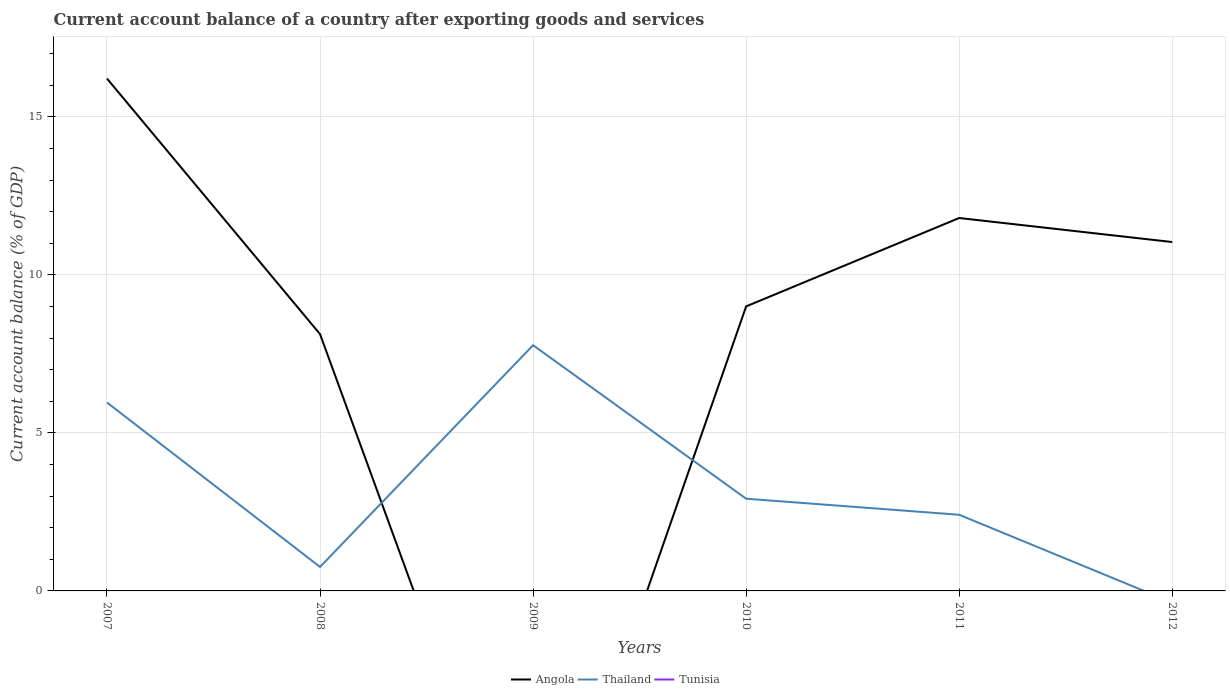How many different coloured lines are there?
Provide a short and direct response. 2. Across all years, what is the maximum account balance in Tunisia?
Offer a terse response. 0. What is the total account balance in Thailand in the graph?
Provide a short and direct response. 5.36. What is the difference between the highest and the second highest account balance in Angola?
Keep it short and to the point. 16.21. What is the difference between the highest and the lowest account balance in Tunisia?
Make the answer very short. 0. Is the account balance in Tunisia strictly greater than the account balance in Angola over the years?
Give a very brief answer. No. What is the difference between two consecutive major ticks on the Y-axis?
Keep it short and to the point. 5. Does the graph contain any zero values?
Your answer should be compact. Yes. Does the graph contain grids?
Make the answer very short. Yes. How many legend labels are there?
Keep it short and to the point. 3. What is the title of the graph?
Offer a terse response. Current account balance of a country after exporting goods and services. Does "Swaziland" appear as one of the legend labels in the graph?
Provide a succinct answer. No. What is the label or title of the Y-axis?
Offer a very short reply. Current account balance (% of GDP). What is the Current account balance (% of GDP) in Angola in 2007?
Give a very brief answer. 16.21. What is the Current account balance (% of GDP) of Thailand in 2007?
Ensure brevity in your answer.  5.96. What is the Current account balance (% of GDP) in Tunisia in 2007?
Provide a short and direct response. 0. What is the Current account balance (% of GDP) of Angola in 2008?
Your answer should be very brief. 8.13. What is the Current account balance (% of GDP) in Thailand in 2008?
Keep it short and to the point. 0.76. What is the Current account balance (% of GDP) in Thailand in 2009?
Your answer should be compact. 7.77. What is the Current account balance (% of GDP) of Tunisia in 2009?
Ensure brevity in your answer.  0. What is the Current account balance (% of GDP) of Angola in 2010?
Give a very brief answer. 9. What is the Current account balance (% of GDP) of Thailand in 2010?
Offer a very short reply. 2.92. What is the Current account balance (% of GDP) of Tunisia in 2010?
Offer a very short reply. 0. What is the Current account balance (% of GDP) in Angola in 2011?
Make the answer very short. 11.8. What is the Current account balance (% of GDP) of Thailand in 2011?
Give a very brief answer. 2.41. What is the Current account balance (% of GDP) of Angola in 2012?
Your answer should be compact. 11.04. Across all years, what is the maximum Current account balance (% of GDP) of Angola?
Your answer should be very brief. 16.21. Across all years, what is the maximum Current account balance (% of GDP) of Thailand?
Make the answer very short. 7.77. What is the total Current account balance (% of GDP) in Angola in the graph?
Provide a short and direct response. 56.18. What is the total Current account balance (% of GDP) in Thailand in the graph?
Make the answer very short. 19.82. What is the difference between the Current account balance (% of GDP) in Angola in 2007 and that in 2008?
Give a very brief answer. 8.09. What is the difference between the Current account balance (% of GDP) in Thailand in 2007 and that in 2008?
Give a very brief answer. 5.2. What is the difference between the Current account balance (% of GDP) in Thailand in 2007 and that in 2009?
Offer a terse response. -1.81. What is the difference between the Current account balance (% of GDP) in Angola in 2007 and that in 2010?
Keep it short and to the point. 7.21. What is the difference between the Current account balance (% of GDP) of Thailand in 2007 and that in 2010?
Offer a very short reply. 3.04. What is the difference between the Current account balance (% of GDP) of Angola in 2007 and that in 2011?
Offer a very short reply. 4.41. What is the difference between the Current account balance (% of GDP) of Thailand in 2007 and that in 2011?
Your response must be concise. 3.55. What is the difference between the Current account balance (% of GDP) of Angola in 2007 and that in 2012?
Your answer should be compact. 5.17. What is the difference between the Current account balance (% of GDP) of Thailand in 2008 and that in 2009?
Give a very brief answer. -7.02. What is the difference between the Current account balance (% of GDP) of Angola in 2008 and that in 2010?
Keep it short and to the point. -0.88. What is the difference between the Current account balance (% of GDP) of Thailand in 2008 and that in 2010?
Ensure brevity in your answer.  -2.16. What is the difference between the Current account balance (% of GDP) of Angola in 2008 and that in 2011?
Your response must be concise. -3.67. What is the difference between the Current account balance (% of GDP) of Thailand in 2008 and that in 2011?
Give a very brief answer. -1.65. What is the difference between the Current account balance (% of GDP) in Angola in 2008 and that in 2012?
Ensure brevity in your answer.  -2.91. What is the difference between the Current account balance (% of GDP) of Thailand in 2009 and that in 2010?
Your answer should be very brief. 4.86. What is the difference between the Current account balance (% of GDP) in Thailand in 2009 and that in 2011?
Provide a succinct answer. 5.36. What is the difference between the Current account balance (% of GDP) of Angola in 2010 and that in 2011?
Your answer should be compact. -2.8. What is the difference between the Current account balance (% of GDP) in Thailand in 2010 and that in 2011?
Keep it short and to the point. 0.51. What is the difference between the Current account balance (% of GDP) in Angola in 2010 and that in 2012?
Keep it short and to the point. -2.04. What is the difference between the Current account balance (% of GDP) in Angola in 2011 and that in 2012?
Your response must be concise. 0.76. What is the difference between the Current account balance (% of GDP) in Angola in 2007 and the Current account balance (% of GDP) in Thailand in 2008?
Make the answer very short. 15.45. What is the difference between the Current account balance (% of GDP) of Angola in 2007 and the Current account balance (% of GDP) of Thailand in 2009?
Provide a succinct answer. 8.44. What is the difference between the Current account balance (% of GDP) in Angola in 2007 and the Current account balance (% of GDP) in Thailand in 2010?
Your answer should be compact. 13.3. What is the difference between the Current account balance (% of GDP) of Angola in 2007 and the Current account balance (% of GDP) of Thailand in 2011?
Your answer should be very brief. 13.8. What is the difference between the Current account balance (% of GDP) of Angola in 2008 and the Current account balance (% of GDP) of Thailand in 2009?
Offer a very short reply. 0.35. What is the difference between the Current account balance (% of GDP) in Angola in 2008 and the Current account balance (% of GDP) in Thailand in 2010?
Your answer should be very brief. 5.21. What is the difference between the Current account balance (% of GDP) in Angola in 2008 and the Current account balance (% of GDP) in Thailand in 2011?
Offer a very short reply. 5.72. What is the difference between the Current account balance (% of GDP) in Angola in 2010 and the Current account balance (% of GDP) in Thailand in 2011?
Offer a terse response. 6.59. What is the average Current account balance (% of GDP) in Angola per year?
Provide a succinct answer. 9.36. What is the average Current account balance (% of GDP) in Thailand per year?
Provide a succinct answer. 3.3. What is the average Current account balance (% of GDP) of Tunisia per year?
Your answer should be very brief. 0. In the year 2007, what is the difference between the Current account balance (% of GDP) in Angola and Current account balance (% of GDP) in Thailand?
Give a very brief answer. 10.25. In the year 2008, what is the difference between the Current account balance (% of GDP) in Angola and Current account balance (% of GDP) in Thailand?
Ensure brevity in your answer.  7.37. In the year 2010, what is the difference between the Current account balance (% of GDP) in Angola and Current account balance (% of GDP) in Thailand?
Offer a very short reply. 6.09. In the year 2011, what is the difference between the Current account balance (% of GDP) in Angola and Current account balance (% of GDP) in Thailand?
Provide a short and direct response. 9.39. What is the ratio of the Current account balance (% of GDP) of Angola in 2007 to that in 2008?
Offer a terse response. 2. What is the ratio of the Current account balance (% of GDP) in Thailand in 2007 to that in 2008?
Make the answer very short. 7.86. What is the ratio of the Current account balance (% of GDP) in Thailand in 2007 to that in 2009?
Your answer should be very brief. 0.77. What is the ratio of the Current account balance (% of GDP) of Angola in 2007 to that in 2010?
Offer a very short reply. 1.8. What is the ratio of the Current account balance (% of GDP) in Thailand in 2007 to that in 2010?
Provide a short and direct response. 2.04. What is the ratio of the Current account balance (% of GDP) of Angola in 2007 to that in 2011?
Your answer should be compact. 1.37. What is the ratio of the Current account balance (% of GDP) in Thailand in 2007 to that in 2011?
Make the answer very short. 2.47. What is the ratio of the Current account balance (% of GDP) of Angola in 2007 to that in 2012?
Keep it short and to the point. 1.47. What is the ratio of the Current account balance (% of GDP) in Thailand in 2008 to that in 2009?
Offer a terse response. 0.1. What is the ratio of the Current account balance (% of GDP) of Angola in 2008 to that in 2010?
Your answer should be very brief. 0.9. What is the ratio of the Current account balance (% of GDP) of Thailand in 2008 to that in 2010?
Your answer should be very brief. 0.26. What is the ratio of the Current account balance (% of GDP) of Angola in 2008 to that in 2011?
Provide a short and direct response. 0.69. What is the ratio of the Current account balance (% of GDP) of Thailand in 2008 to that in 2011?
Keep it short and to the point. 0.31. What is the ratio of the Current account balance (% of GDP) of Angola in 2008 to that in 2012?
Ensure brevity in your answer.  0.74. What is the ratio of the Current account balance (% of GDP) in Thailand in 2009 to that in 2010?
Make the answer very short. 2.66. What is the ratio of the Current account balance (% of GDP) in Thailand in 2009 to that in 2011?
Your response must be concise. 3.23. What is the ratio of the Current account balance (% of GDP) of Angola in 2010 to that in 2011?
Your answer should be compact. 0.76. What is the ratio of the Current account balance (% of GDP) of Thailand in 2010 to that in 2011?
Offer a terse response. 1.21. What is the ratio of the Current account balance (% of GDP) in Angola in 2010 to that in 2012?
Your answer should be very brief. 0.82. What is the ratio of the Current account balance (% of GDP) of Angola in 2011 to that in 2012?
Your response must be concise. 1.07. What is the difference between the highest and the second highest Current account balance (% of GDP) of Angola?
Ensure brevity in your answer.  4.41. What is the difference between the highest and the second highest Current account balance (% of GDP) of Thailand?
Make the answer very short. 1.81. What is the difference between the highest and the lowest Current account balance (% of GDP) of Angola?
Ensure brevity in your answer.  16.21. What is the difference between the highest and the lowest Current account balance (% of GDP) in Thailand?
Give a very brief answer. 7.77. 